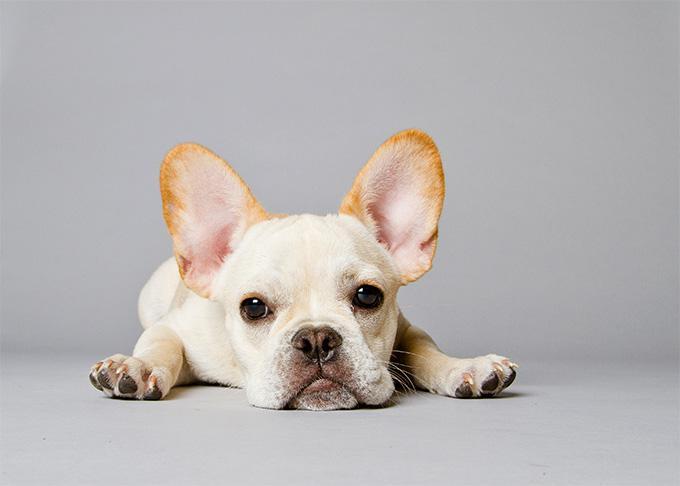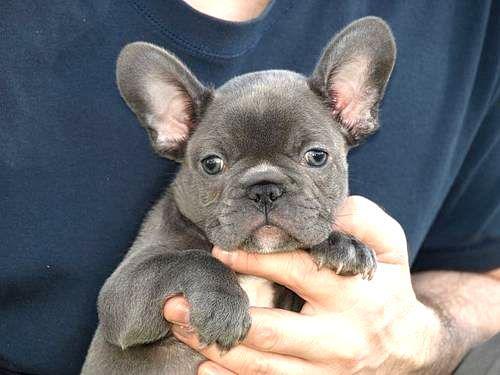The first image is the image on the left, the second image is the image on the right. Given the left and right images, does the statement "Two dogs are posing together in the image on the left." hold true? Answer yes or no. No. The first image is the image on the left, the second image is the image on the right. Assess this claim about the two images: "The left image includes exactly twice as many dogs as the right image.". Correct or not? Answer yes or no. No. 